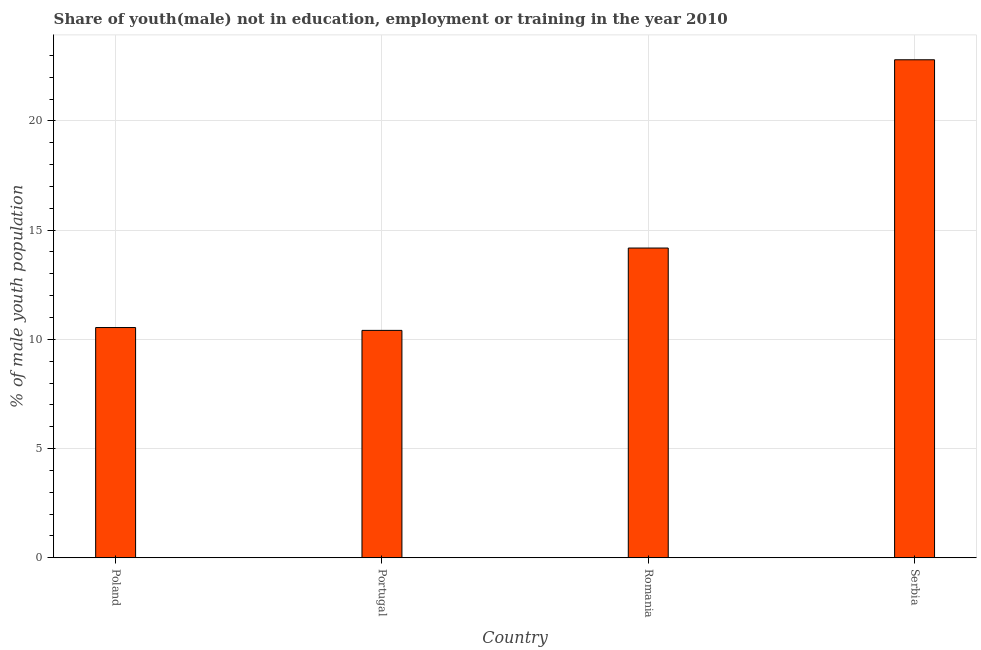Does the graph contain any zero values?
Offer a terse response. No. Does the graph contain grids?
Keep it short and to the point. Yes. What is the title of the graph?
Ensure brevity in your answer.  Share of youth(male) not in education, employment or training in the year 2010. What is the label or title of the X-axis?
Your answer should be compact. Country. What is the label or title of the Y-axis?
Your answer should be very brief. % of male youth population. What is the unemployed male youth population in Serbia?
Your answer should be compact. 22.8. Across all countries, what is the maximum unemployed male youth population?
Ensure brevity in your answer.  22.8. Across all countries, what is the minimum unemployed male youth population?
Make the answer very short. 10.41. In which country was the unemployed male youth population maximum?
Provide a succinct answer. Serbia. What is the sum of the unemployed male youth population?
Offer a very short reply. 57.93. What is the difference between the unemployed male youth population in Portugal and Serbia?
Ensure brevity in your answer.  -12.39. What is the average unemployed male youth population per country?
Offer a very short reply. 14.48. What is the median unemployed male youth population?
Your answer should be compact. 12.36. In how many countries, is the unemployed male youth population greater than 10 %?
Ensure brevity in your answer.  4. What is the ratio of the unemployed male youth population in Poland to that in Serbia?
Your response must be concise. 0.46. Is the difference between the unemployed male youth population in Portugal and Romania greater than the difference between any two countries?
Offer a terse response. No. What is the difference between the highest and the second highest unemployed male youth population?
Give a very brief answer. 8.62. What is the difference between the highest and the lowest unemployed male youth population?
Ensure brevity in your answer.  12.39. In how many countries, is the unemployed male youth population greater than the average unemployed male youth population taken over all countries?
Give a very brief answer. 1. How many bars are there?
Offer a terse response. 4. Are the values on the major ticks of Y-axis written in scientific E-notation?
Provide a short and direct response. No. What is the % of male youth population in Poland?
Your response must be concise. 10.54. What is the % of male youth population of Portugal?
Ensure brevity in your answer.  10.41. What is the % of male youth population of Romania?
Ensure brevity in your answer.  14.18. What is the % of male youth population in Serbia?
Provide a succinct answer. 22.8. What is the difference between the % of male youth population in Poland and Portugal?
Your answer should be compact. 0.13. What is the difference between the % of male youth population in Poland and Romania?
Provide a short and direct response. -3.64. What is the difference between the % of male youth population in Poland and Serbia?
Provide a succinct answer. -12.26. What is the difference between the % of male youth population in Portugal and Romania?
Your response must be concise. -3.77. What is the difference between the % of male youth population in Portugal and Serbia?
Ensure brevity in your answer.  -12.39. What is the difference between the % of male youth population in Romania and Serbia?
Keep it short and to the point. -8.62. What is the ratio of the % of male youth population in Poland to that in Romania?
Offer a terse response. 0.74. What is the ratio of the % of male youth population in Poland to that in Serbia?
Make the answer very short. 0.46. What is the ratio of the % of male youth population in Portugal to that in Romania?
Give a very brief answer. 0.73. What is the ratio of the % of male youth population in Portugal to that in Serbia?
Ensure brevity in your answer.  0.46. What is the ratio of the % of male youth population in Romania to that in Serbia?
Offer a terse response. 0.62. 